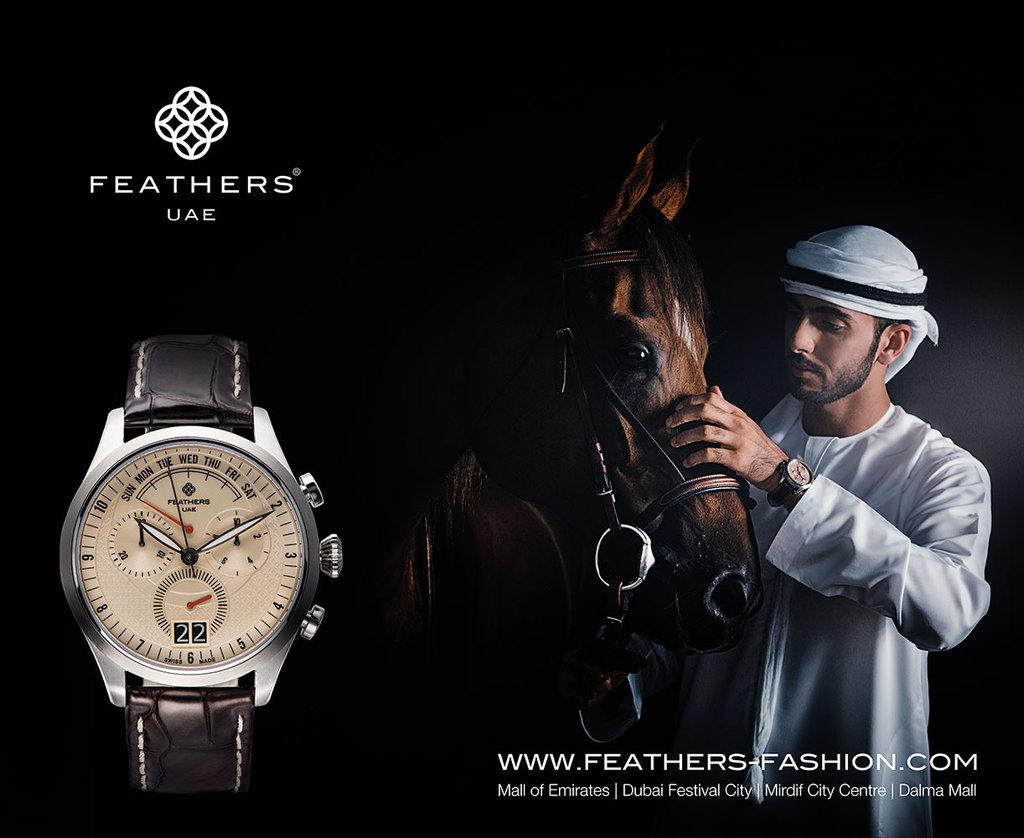What brand of watch?
Provide a short and direct response. Feathers. 